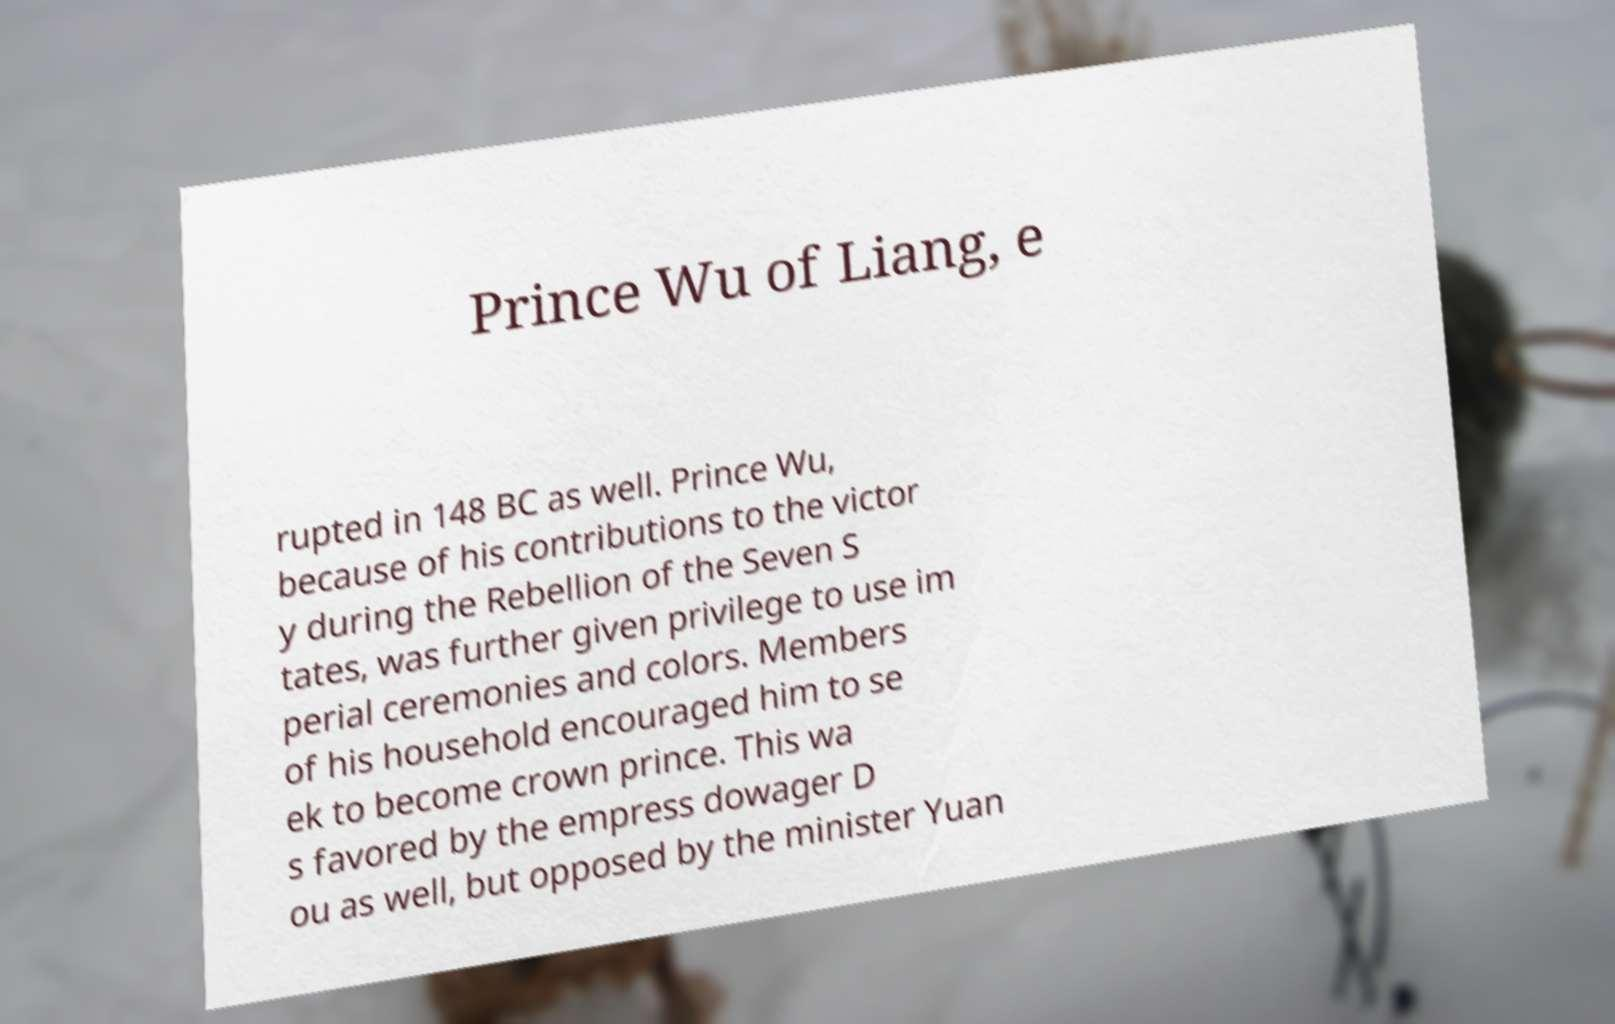Can you accurately transcribe the text from the provided image for me? Prince Wu of Liang, e rupted in 148 BC as well. Prince Wu, because of his contributions to the victor y during the Rebellion of the Seven S tates, was further given privilege to use im perial ceremonies and colors. Members of his household encouraged him to se ek to become crown prince. This wa s favored by the empress dowager D ou as well, but opposed by the minister Yuan 